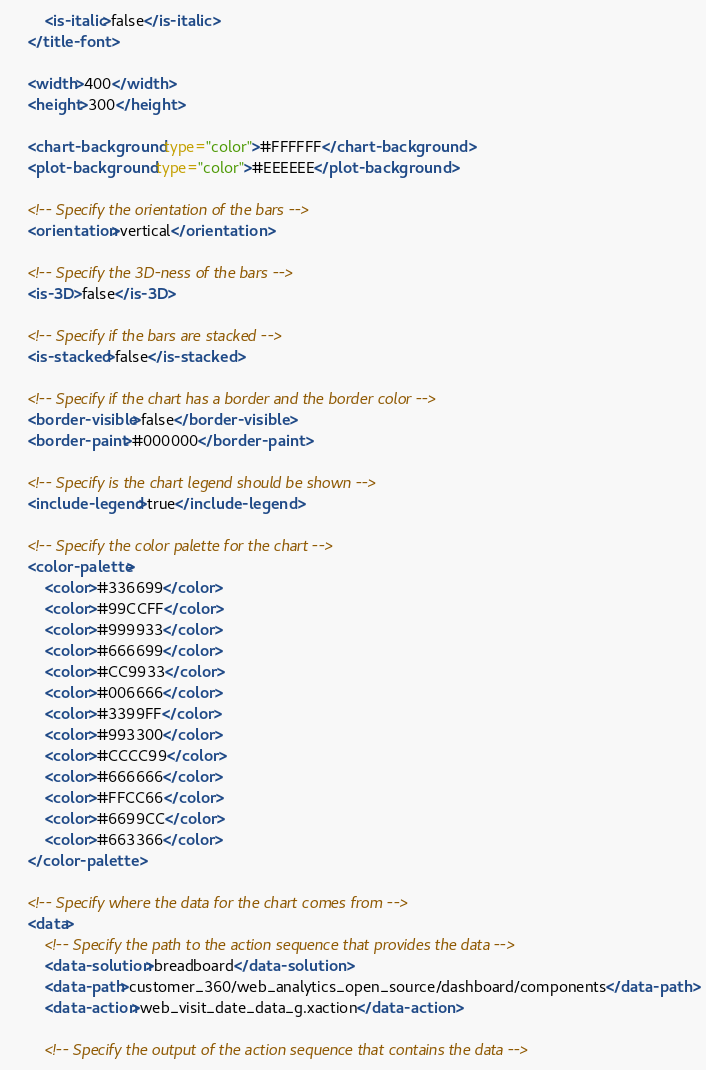<code> <loc_0><loc_0><loc_500><loc_500><_XML_>		<is-italic>false</is-italic>
	</title-font>

	<width>400</width>
	<height>300</height>

	<chart-background type="color">#FFFFFF</chart-background>
	<plot-background type="color">#EEEEEE</plot-background>

	<!-- Specify the orientation of the bars -->
	<orientation>vertical</orientation>

	<!-- Specify the 3D-ness of the bars -->
	<is-3D>false</is-3D>

	<!-- Specify if the bars are stacked -->
	<is-stacked>false</is-stacked>

	<!-- Specify if the chart has a border and the border color -->
	<border-visible>false</border-visible>
	<border-paint>#000000</border-paint>

	<!-- Specify is the chart legend should be shown -->
	<include-legend>true</include-legend>
	
	<!-- Specify the color palette for the chart -->
	<color-palette>
		<color>#336699</color>
		<color>#99CCFF</color>
		<color>#999933</color>
		<color>#666699</color>
		<color>#CC9933</color>
		<color>#006666</color>
		<color>#3399FF</color>
		<color>#993300</color>
		<color>#CCCC99</color>
		<color>#666666</color>
		<color>#FFCC66</color>
		<color>#6699CC</color>
		<color>#663366</color>
	</color-palette>

	<!-- Specify where the data for the chart comes from -->
	<data>
		<!-- Specify the path to the action sequence that provides the data -->
		<data-solution>breadboard</data-solution>
		<data-path>customer_360/web_analytics_open_source/dashboard/components</data-path>
		<data-action>web_visit_date_data_g.xaction</data-action>

		<!-- Specify the output of the action sequence that contains the data --></code> 